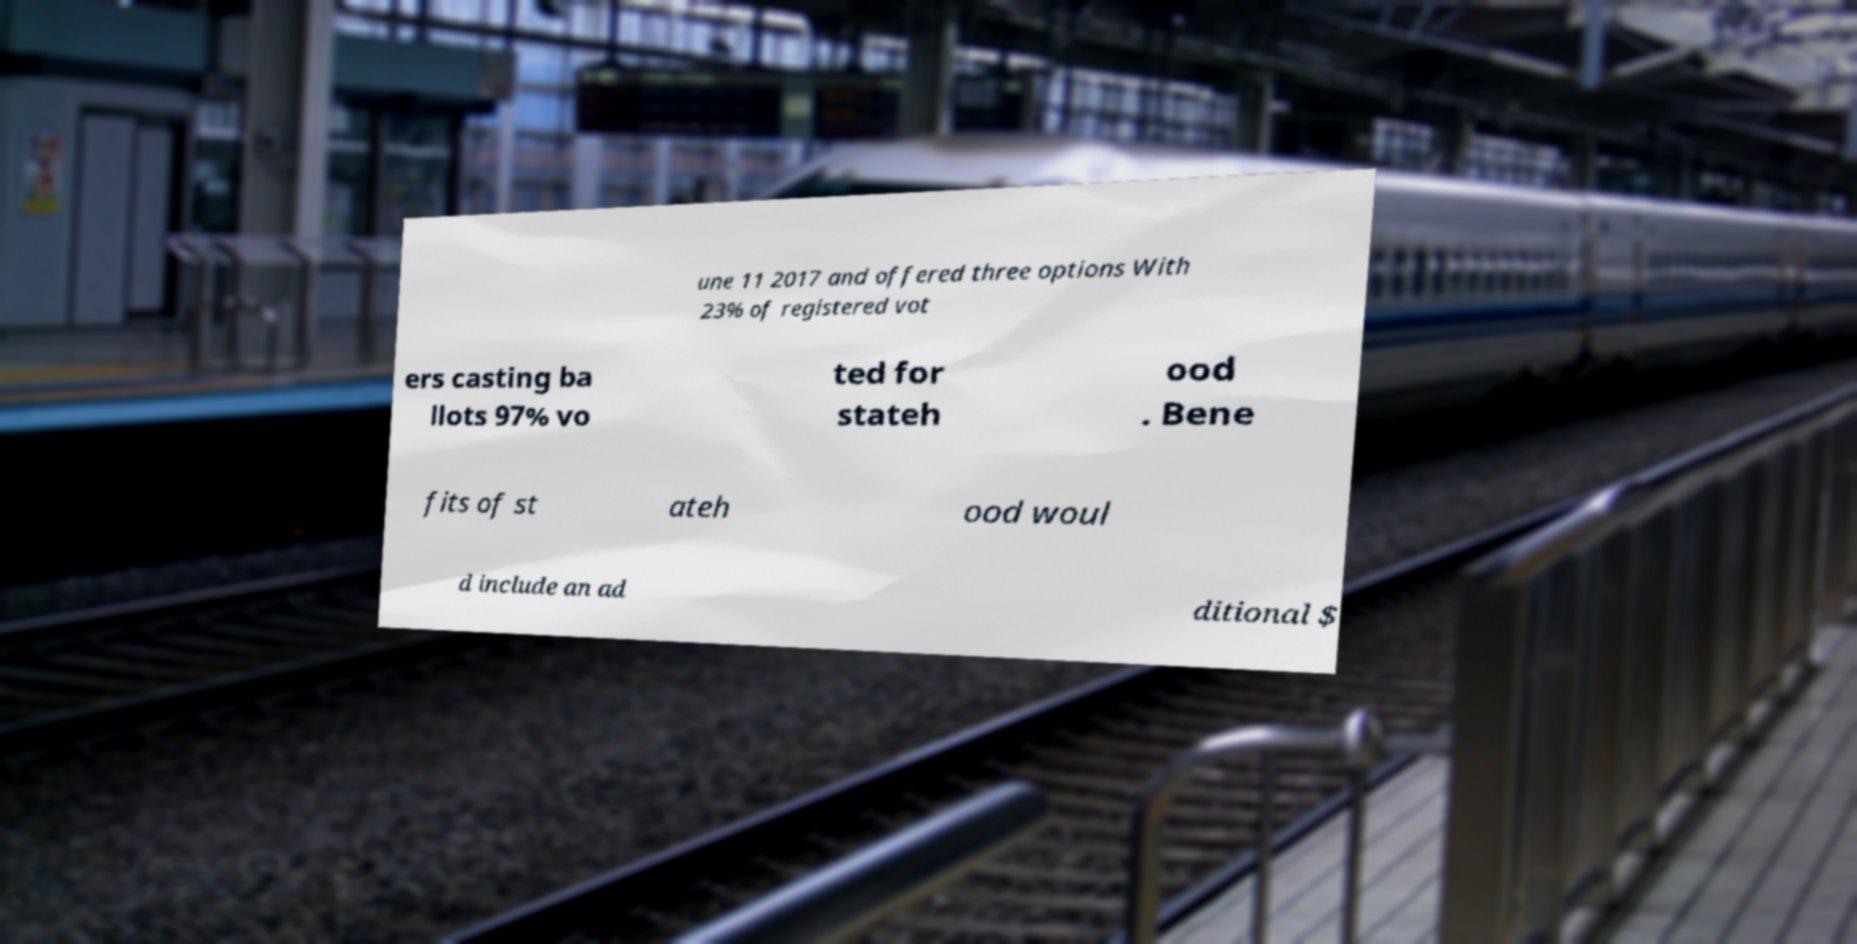I need the written content from this picture converted into text. Can you do that? une 11 2017 and offered three options With 23% of registered vot ers casting ba llots 97% vo ted for stateh ood . Bene fits of st ateh ood woul d include an ad ditional $ 